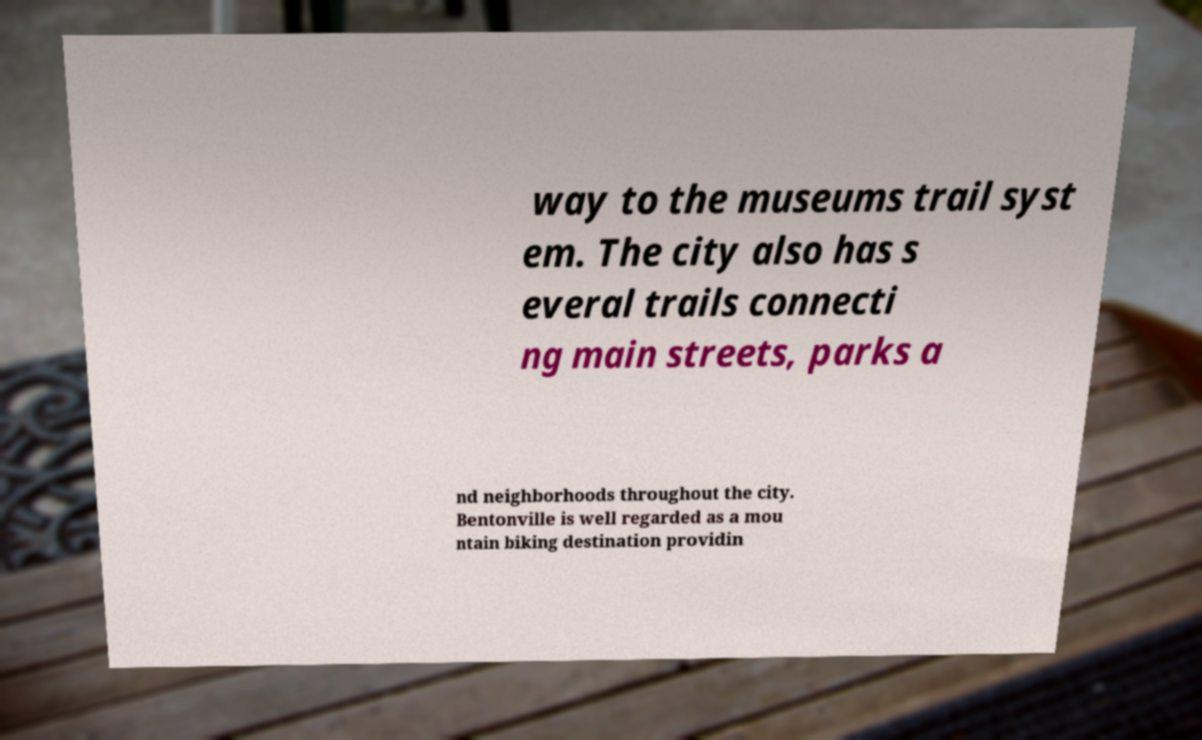There's text embedded in this image that I need extracted. Can you transcribe it verbatim? way to the museums trail syst em. The city also has s everal trails connecti ng main streets, parks a nd neighborhoods throughout the city. Bentonville is well regarded as a mou ntain biking destination providin 